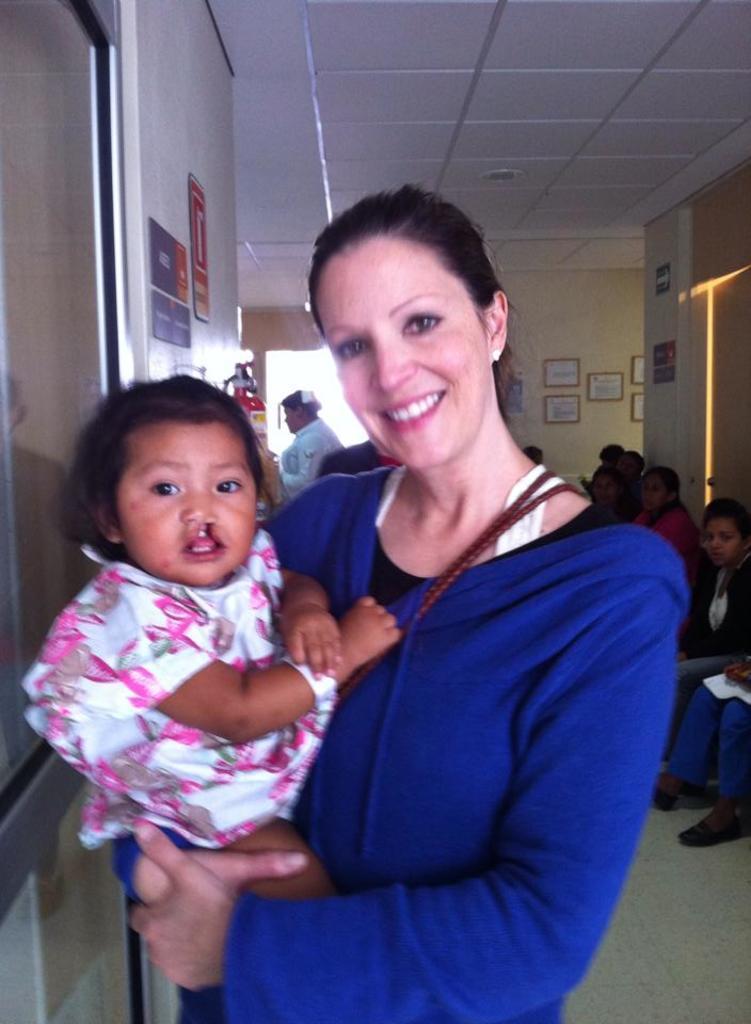How would you summarize this image in a sentence or two? In this image, we can see a woman is carrying a baby and smiling. They both are watching. Background we can see walls, poster, fire extinguisher, people, photo frames, door and some objects. On the right side bottom corner, we can see the floor. Top of the image, we can see the ceiling. 